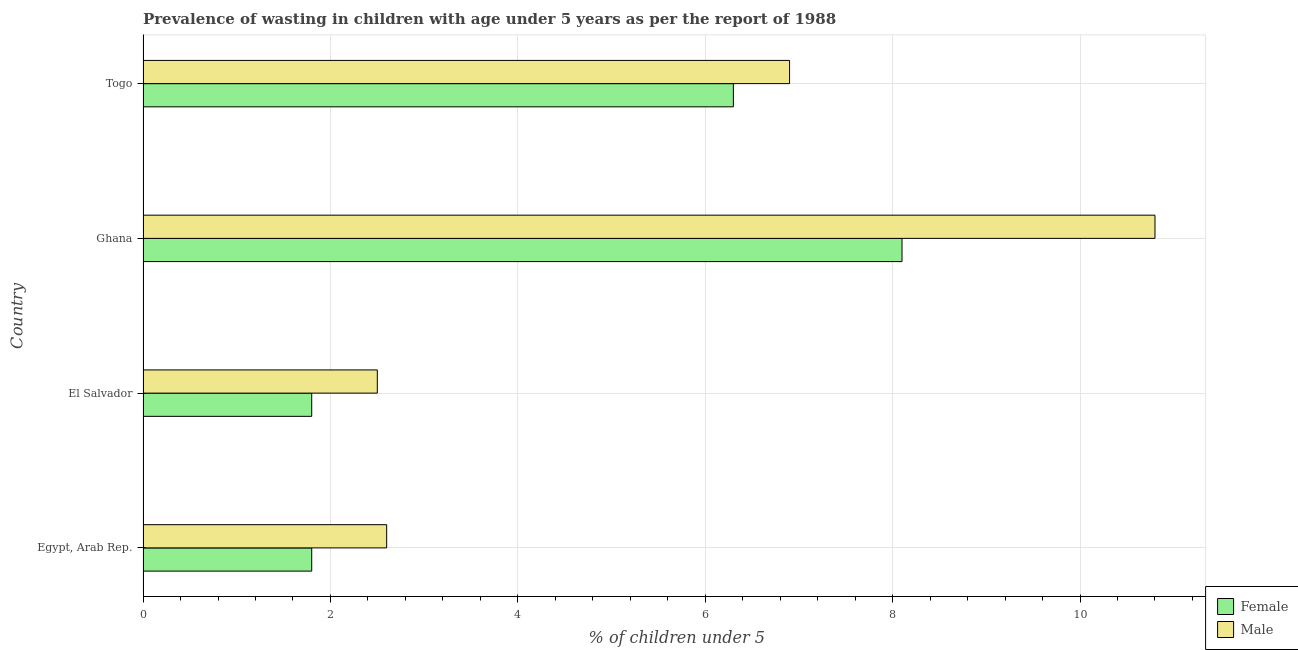How many groups of bars are there?
Ensure brevity in your answer.  4. Are the number of bars on each tick of the Y-axis equal?
Make the answer very short. Yes. How many bars are there on the 4th tick from the top?
Make the answer very short. 2. What is the label of the 3rd group of bars from the top?
Your answer should be very brief. El Salvador. What is the percentage of undernourished female children in Ghana?
Keep it short and to the point. 8.1. Across all countries, what is the maximum percentage of undernourished female children?
Provide a short and direct response. 8.1. Across all countries, what is the minimum percentage of undernourished female children?
Your answer should be compact. 1.8. In which country was the percentage of undernourished female children minimum?
Ensure brevity in your answer.  Egypt, Arab Rep. What is the total percentage of undernourished female children in the graph?
Ensure brevity in your answer.  18. What is the difference between the percentage of undernourished male children in Togo and the percentage of undernourished female children in El Salvador?
Offer a terse response. 5.1. What is the average percentage of undernourished male children per country?
Offer a very short reply. 5.7. What is the difference between the percentage of undernourished male children and percentage of undernourished female children in Ghana?
Make the answer very short. 2.7. What is the ratio of the percentage of undernourished female children in Egypt, Arab Rep. to that in Togo?
Keep it short and to the point. 0.29. Is the difference between the percentage of undernourished female children in Egypt, Arab Rep. and Togo greater than the difference between the percentage of undernourished male children in Egypt, Arab Rep. and Togo?
Offer a terse response. No. What is the difference between two consecutive major ticks on the X-axis?
Your answer should be compact. 2. Are the values on the major ticks of X-axis written in scientific E-notation?
Offer a terse response. No. Does the graph contain grids?
Keep it short and to the point. Yes. What is the title of the graph?
Offer a very short reply. Prevalence of wasting in children with age under 5 years as per the report of 1988. What is the label or title of the X-axis?
Offer a very short reply.  % of children under 5. What is the label or title of the Y-axis?
Offer a terse response. Country. What is the  % of children under 5 of Female in Egypt, Arab Rep.?
Keep it short and to the point. 1.8. What is the  % of children under 5 in Male in Egypt, Arab Rep.?
Your answer should be very brief. 2.6. What is the  % of children under 5 in Female in El Salvador?
Offer a very short reply. 1.8. What is the  % of children under 5 of Male in El Salvador?
Keep it short and to the point. 2.5. What is the  % of children under 5 in Female in Ghana?
Offer a very short reply. 8.1. What is the  % of children under 5 in Male in Ghana?
Provide a short and direct response. 10.8. What is the  % of children under 5 of Female in Togo?
Offer a terse response. 6.3. What is the  % of children under 5 of Male in Togo?
Give a very brief answer. 6.9. Across all countries, what is the maximum  % of children under 5 of Female?
Offer a terse response. 8.1. Across all countries, what is the maximum  % of children under 5 in Male?
Ensure brevity in your answer.  10.8. Across all countries, what is the minimum  % of children under 5 of Female?
Your answer should be very brief. 1.8. Across all countries, what is the minimum  % of children under 5 of Male?
Offer a very short reply. 2.5. What is the total  % of children under 5 in Male in the graph?
Your answer should be compact. 22.8. What is the difference between the  % of children under 5 of Male in Egypt, Arab Rep. and that in El Salvador?
Provide a short and direct response. 0.1. What is the difference between the  % of children under 5 of Female in Egypt, Arab Rep. and that in Ghana?
Provide a succinct answer. -6.3. What is the difference between the  % of children under 5 of Female in El Salvador and that in Ghana?
Your response must be concise. -6.3. What is the difference between the  % of children under 5 of Female in El Salvador and that in Togo?
Your answer should be compact. -4.5. What is the difference between the  % of children under 5 of Male in El Salvador and that in Togo?
Offer a terse response. -4.4. What is the difference between the  % of children under 5 in Male in Ghana and that in Togo?
Your response must be concise. 3.9. What is the difference between the  % of children under 5 of Female in Egypt, Arab Rep. and the  % of children under 5 of Male in Ghana?
Your response must be concise. -9. What is the difference between the  % of children under 5 of Female in El Salvador and the  % of children under 5 of Male in Togo?
Provide a succinct answer. -5.1. What is the average  % of children under 5 of Female per country?
Make the answer very short. 4.5. What is the average  % of children under 5 of Male per country?
Provide a succinct answer. 5.7. What is the difference between the  % of children under 5 in Female and  % of children under 5 in Male in Ghana?
Provide a succinct answer. -2.7. What is the ratio of the  % of children under 5 in Female in Egypt, Arab Rep. to that in El Salvador?
Keep it short and to the point. 1. What is the ratio of the  % of children under 5 of Female in Egypt, Arab Rep. to that in Ghana?
Provide a short and direct response. 0.22. What is the ratio of the  % of children under 5 in Male in Egypt, Arab Rep. to that in Ghana?
Your answer should be compact. 0.24. What is the ratio of the  % of children under 5 in Female in Egypt, Arab Rep. to that in Togo?
Your answer should be very brief. 0.29. What is the ratio of the  % of children under 5 in Male in Egypt, Arab Rep. to that in Togo?
Provide a short and direct response. 0.38. What is the ratio of the  % of children under 5 of Female in El Salvador to that in Ghana?
Your answer should be compact. 0.22. What is the ratio of the  % of children under 5 in Male in El Salvador to that in Ghana?
Your response must be concise. 0.23. What is the ratio of the  % of children under 5 of Female in El Salvador to that in Togo?
Your answer should be very brief. 0.29. What is the ratio of the  % of children under 5 in Male in El Salvador to that in Togo?
Provide a short and direct response. 0.36. What is the ratio of the  % of children under 5 in Male in Ghana to that in Togo?
Your response must be concise. 1.57. 